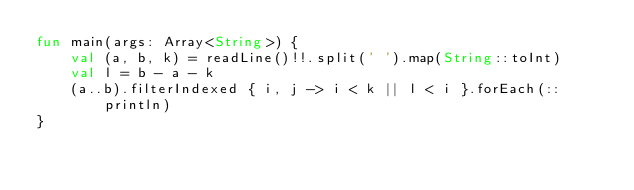Convert code to text. <code><loc_0><loc_0><loc_500><loc_500><_Kotlin_>fun main(args: Array<String>) {
    val (a, b, k) = readLine()!!.split(' ').map(String::toInt)
    val l = b - a - k
    (a..b).filterIndexed { i, j -> i < k || l < i }.forEach(::println)
}
</code> 